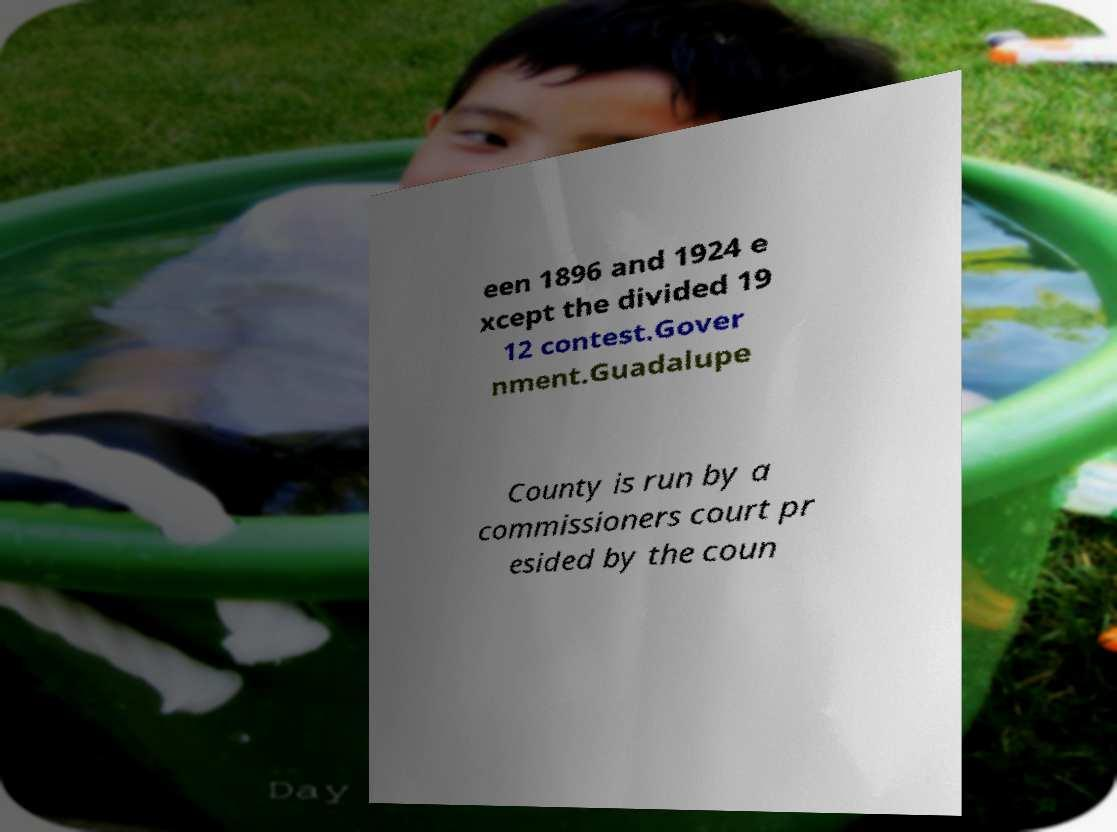Can you read and provide the text displayed in the image?This photo seems to have some interesting text. Can you extract and type it out for me? een 1896 and 1924 e xcept the divided 19 12 contest.Gover nment.Guadalupe County is run by a commissioners court pr esided by the coun 